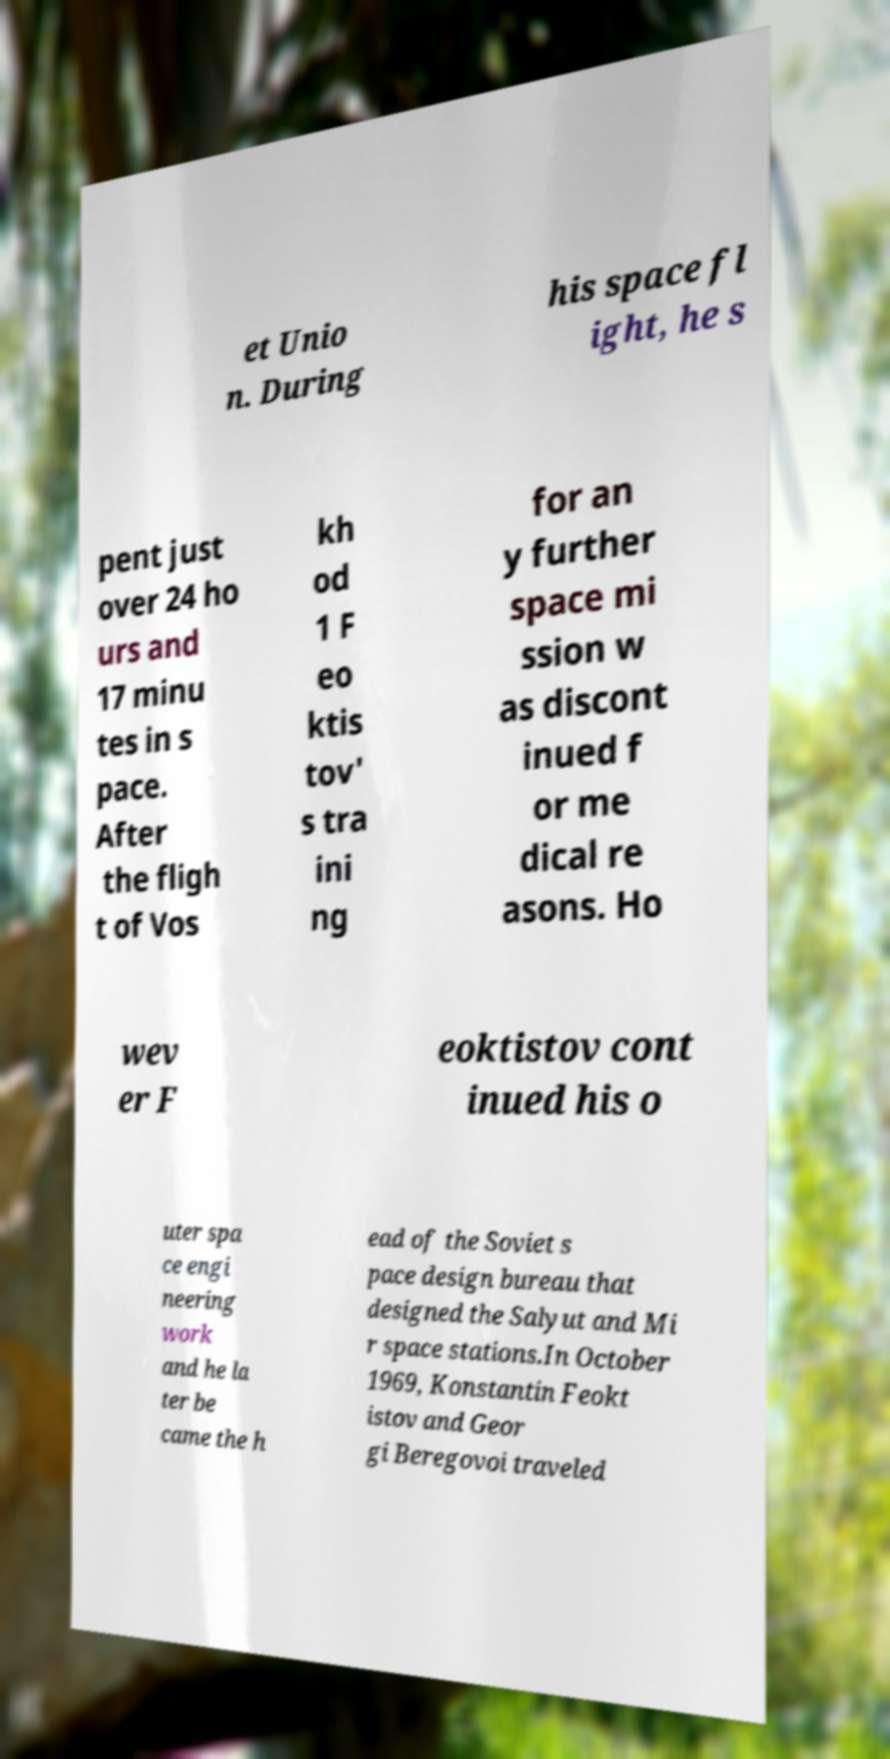Could you extract and type out the text from this image? et Unio n. During his space fl ight, he s pent just over 24 ho urs and 17 minu tes in s pace. After the fligh t of Vos kh od 1 F eo ktis tov' s tra ini ng for an y further space mi ssion w as discont inued f or me dical re asons. Ho wev er F eoktistov cont inued his o uter spa ce engi neering work and he la ter be came the h ead of the Soviet s pace design bureau that designed the Salyut and Mi r space stations.In October 1969, Konstantin Feokt istov and Geor gi Beregovoi traveled 